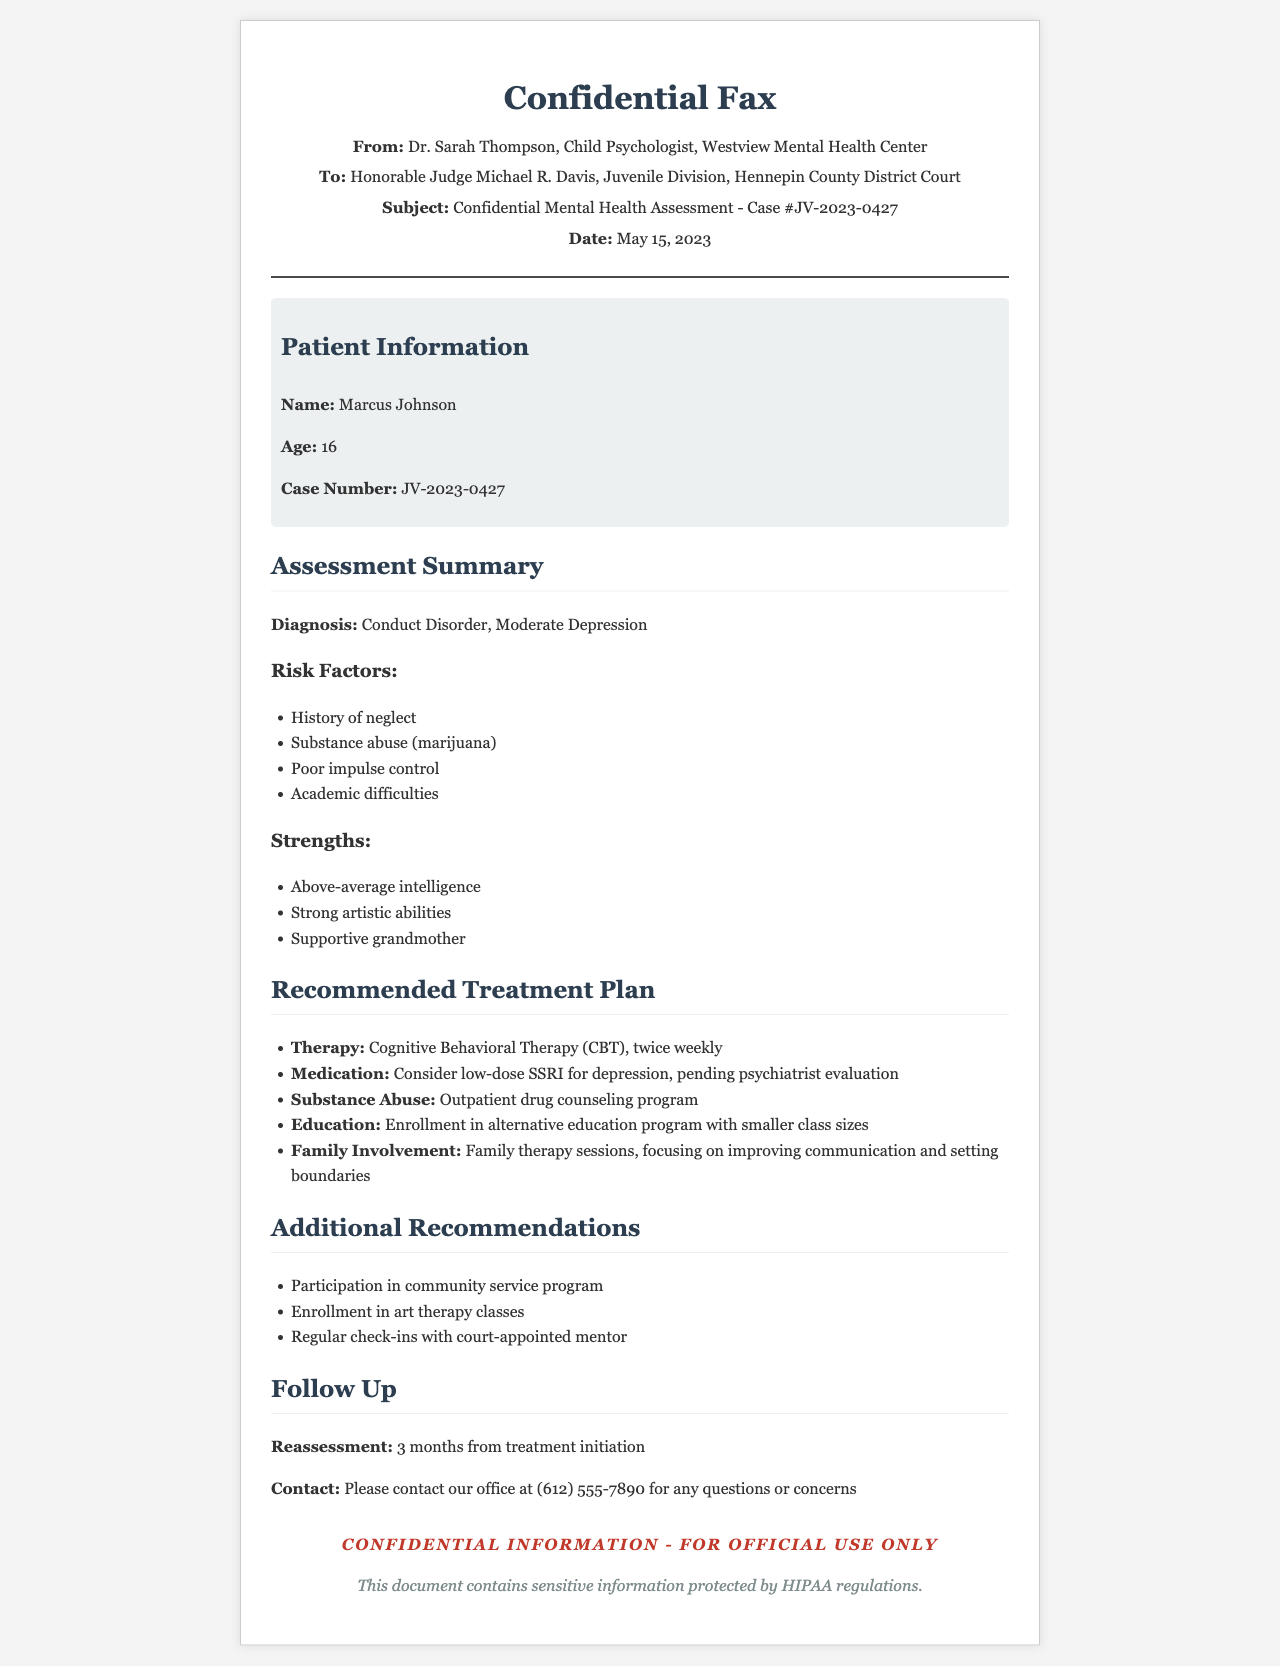What is the name of the patient? The patient’s name is specified in the patient information section of the fax.
Answer: Marcus Johnson What is the age of Marcus Johnson? The age of Marcus Johnson is mentioned in the patient information section.
Answer: 16 What is the diagnosis provided in the assessment? The diagnosis can be found in the assessment summary of the fax.
Answer: Conduct Disorder, Moderate Depression How many weekly therapy sessions are recommended? The recommended number of therapy sessions is detailed in the treatment plan section.
Answer: Twice weekly What substance abuse issue is noted in the assessment? The specific substance abuse issue is listed under risk factors in the assessment summary.
Answer: Marijuana What type of therapy is recommended for Marcus? The type of therapy recommended is found in the recommended treatment plan section.
Answer: Cognitive Behavioral Therapy (CBT) What is the reassessment timeline? The reassessment timeline is stated in the follow-up section of the document.
Answer: 3 months from treatment initiation Who is the sender of the fax? The sender's name is provided at the top of the fax.
Answer: Dr. Sarah Thompson What type of involvement is suggested for the family? The family involvement strategy is found in the recommended treatment plan section.
Answer: Family therapy sessions What is the contact number provided for questions? The contact number for questions is listed in the follow-up section.
Answer: (612) 555-7890 